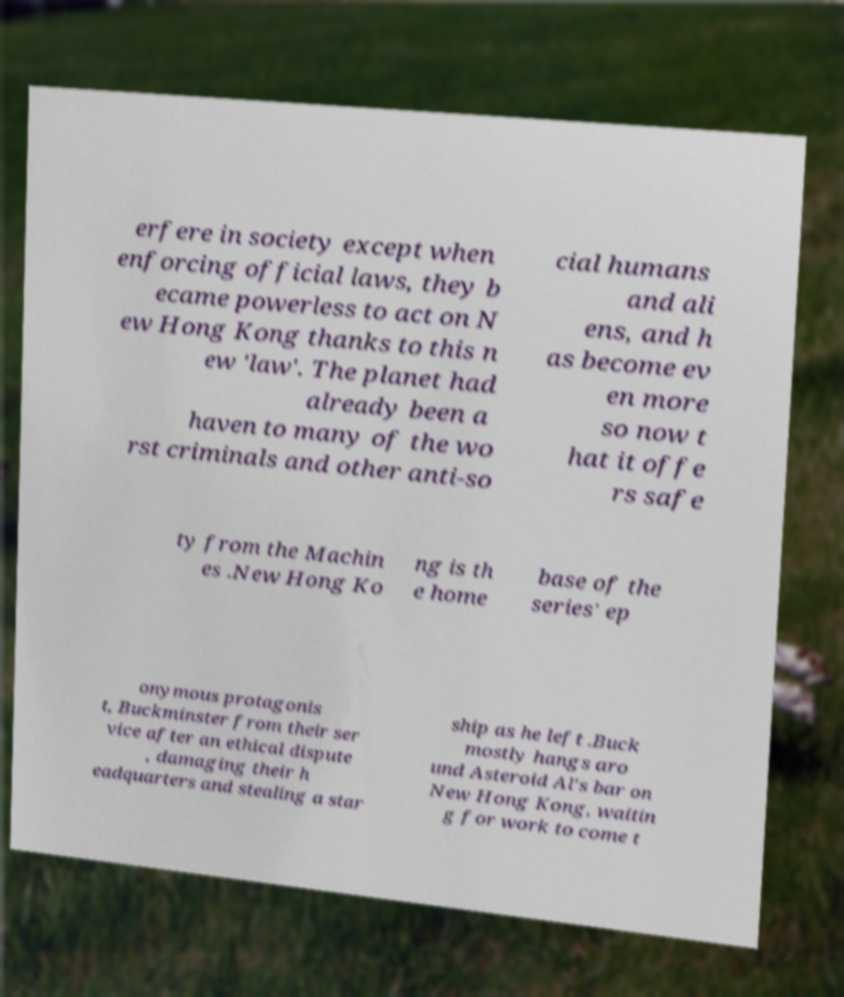Please identify and transcribe the text found in this image. erfere in society except when enforcing official laws, they b ecame powerless to act on N ew Hong Kong thanks to this n ew 'law'. The planet had already been a haven to many of the wo rst criminals and other anti-so cial humans and ali ens, and h as become ev en more so now t hat it offe rs safe ty from the Machin es .New Hong Ko ng is th e home base of the series' ep onymous protagonis t, Buckminster from their ser vice after an ethical dispute , damaging their h eadquarters and stealing a star ship as he left .Buck mostly hangs aro und Asteroid Al's bar on New Hong Kong, waitin g for work to come t 